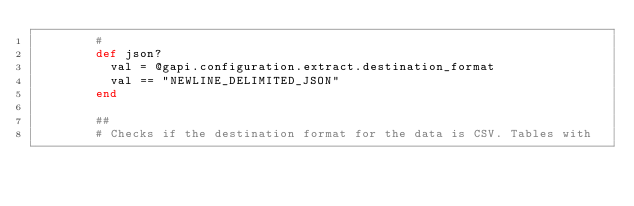<code> <loc_0><loc_0><loc_500><loc_500><_Ruby_>        #
        def json?
          val = @gapi.configuration.extract.destination_format
          val == "NEWLINE_DELIMITED_JSON"
        end

        ##
        # Checks if the destination format for the data is CSV. Tables with</code> 